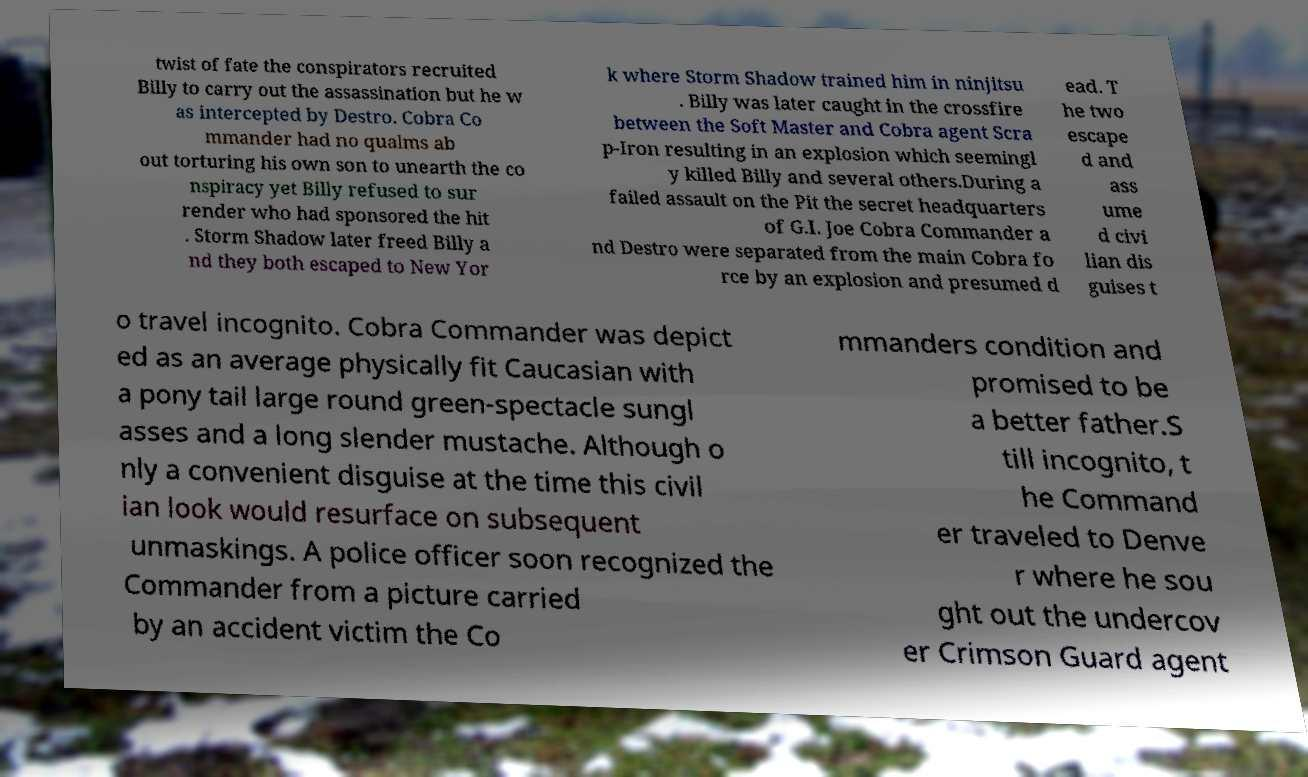Could you extract and type out the text from this image? twist of fate the conspirators recruited Billy to carry out the assassination but he w as intercepted by Destro. Cobra Co mmander had no qualms ab out torturing his own son to unearth the co nspiracy yet Billy refused to sur render who had sponsored the hit . Storm Shadow later freed Billy a nd they both escaped to New Yor k where Storm Shadow trained him in ninjitsu . Billy was later caught in the crossfire between the Soft Master and Cobra agent Scra p-Iron resulting in an explosion which seemingl y killed Billy and several others.During a failed assault on the Pit the secret headquarters of G.I. Joe Cobra Commander a nd Destro were separated from the main Cobra fo rce by an explosion and presumed d ead. T he two escape d and ass ume d civi lian dis guises t o travel incognito. Cobra Commander was depict ed as an average physically fit Caucasian with a pony tail large round green-spectacle sungl asses and a long slender mustache. Although o nly a convenient disguise at the time this civil ian look would resurface on subsequent unmaskings. A police officer soon recognized the Commander from a picture carried by an accident victim the Co mmanders condition and promised to be a better father.S till incognito, t he Command er traveled to Denve r where he sou ght out the undercov er Crimson Guard agent 